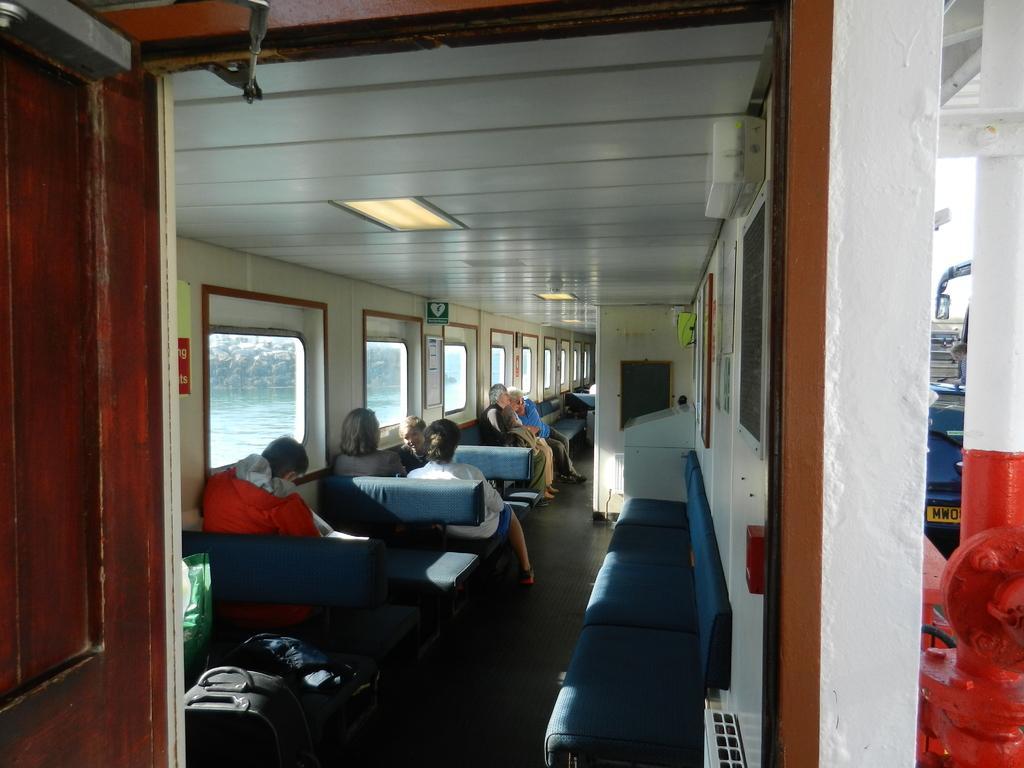Can you describe this image briefly? In this picture we can see a group of people sitting and in the background we can see windows,from windows we can see water. 